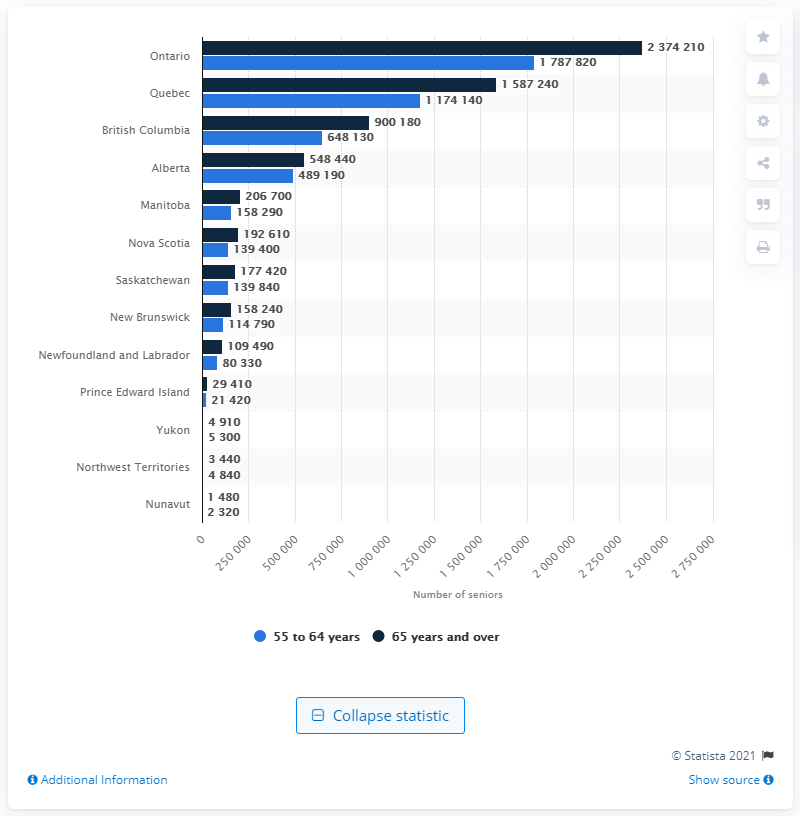Highlight a few significant elements in this photo. In 2018, it is estimated that approximately 2,374,210 people aged 65 and over lived in the province of Ontario. 